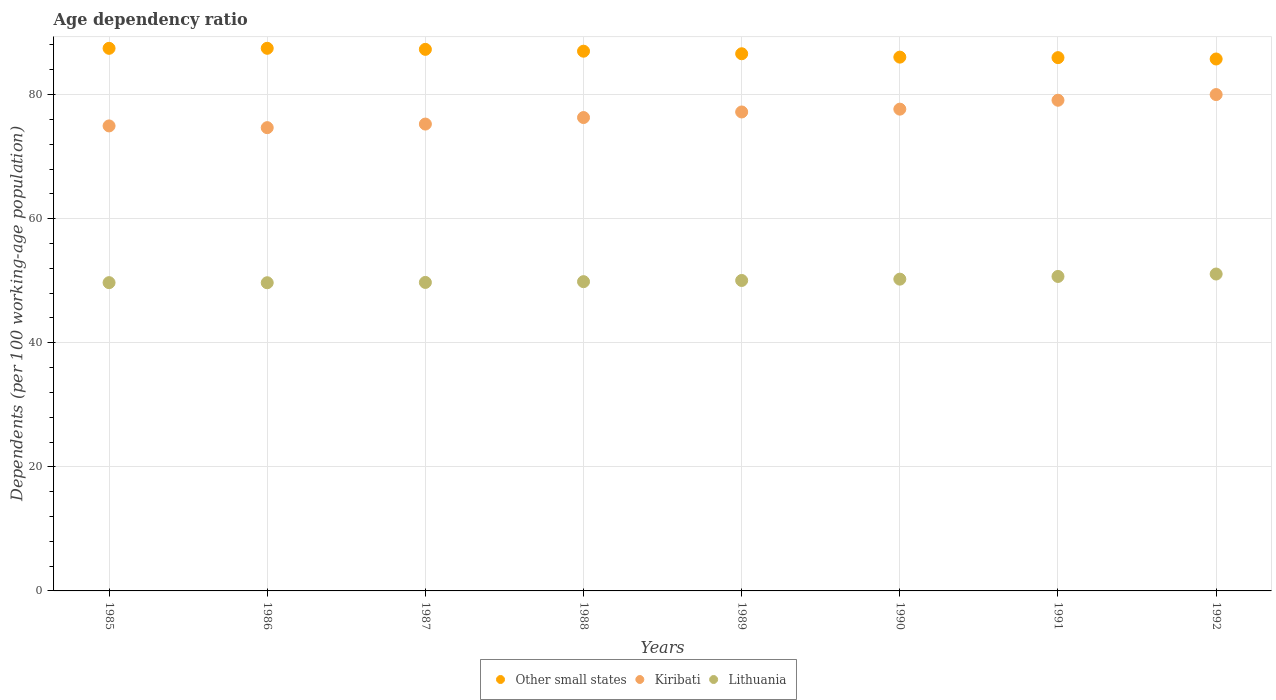How many different coloured dotlines are there?
Keep it short and to the point. 3. Is the number of dotlines equal to the number of legend labels?
Ensure brevity in your answer.  Yes. What is the age dependency ratio in in Lithuania in 1992?
Offer a terse response. 51.08. Across all years, what is the maximum age dependency ratio in in Kiribati?
Offer a terse response. 80. Across all years, what is the minimum age dependency ratio in in Kiribati?
Make the answer very short. 74.67. In which year was the age dependency ratio in in Kiribati minimum?
Offer a terse response. 1986. What is the total age dependency ratio in in Other small states in the graph?
Keep it short and to the point. 693.47. What is the difference between the age dependency ratio in in Other small states in 1989 and that in 1992?
Offer a very short reply. 0.84. What is the difference between the age dependency ratio in in Other small states in 1989 and the age dependency ratio in in Kiribati in 1986?
Ensure brevity in your answer.  11.91. What is the average age dependency ratio in in Other small states per year?
Give a very brief answer. 86.68. In the year 1986, what is the difference between the age dependency ratio in in Lithuania and age dependency ratio in in Kiribati?
Keep it short and to the point. -25. In how many years, is the age dependency ratio in in Other small states greater than 48 %?
Give a very brief answer. 8. What is the ratio of the age dependency ratio in in Kiribati in 1988 to that in 1990?
Give a very brief answer. 0.98. Is the age dependency ratio in in Other small states in 1990 less than that in 1991?
Your response must be concise. No. Is the difference between the age dependency ratio in in Lithuania in 1987 and 1992 greater than the difference between the age dependency ratio in in Kiribati in 1987 and 1992?
Offer a terse response. Yes. What is the difference between the highest and the second highest age dependency ratio in in Kiribati?
Your answer should be compact. 0.92. What is the difference between the highest and the lowest age dependency ratio in in Kiribati?
Offer a terse response. 5.33. Is it the case that in every year, the sum of the age dependency ratio in in Other small states and age dependency ratio in in Lithuania  is greater than the age dependency ratio in in Kiribati?
Provide a succinct answer. Yes. Is the age dependency ratio in in Lithuania strictly greater than the age dependency ratio in in Other small states over the years?
Provide a short and direct response. No. Is the age dependency ratio in in Other small states strictly less than the age dependency ratio in in Kiribati over the years?
Give a very brief answer. No. What is the title of the graph?
Provide a short and direct response. Age dependency ratio. Does "Argentina" appear as one of the legend labels in the graph?
Give a very brief answer. No. What is the label or title of the Y-axis?
Your answer should be compact. Dependents (per 100 working-age population). What is the Dependents (per 100 working-age population) of Other small states in 1985?
Offer a very short reply. 87.45. What is the Dependents (per 100 working-age population) of Kiribati in 1985?
Ensure brevity in your answer.  74.95. What is the Dependents (per 100 working-age population) of Lithuania in 1985?
Give a very brief answer. 49.69. What is the Dependents (per 100 working-age population) in Other small states in 1986?
Provide a short and direct response. 87.46. What is the Dependents (per 100 working-age population) of Kiribati in 1986?
Give a very brief answer. 74.67. What is the Dependents (per 100 working-age population) of Lithuania in 1986?
Your response must be concise. 49.67. What is the Dependents (per 100 working-age population) of Other small states in 1987?
Keep it short and to the point. 87.29. What is the Dependents (per 100 working-age population) in Kiribati in 1987?
Provide a succinct answer. 75.24. What is the Dependents (per 100 working-age population) of Lithuania in 1987?
Provide a succinct answer. 49.72. What is the Dependents (per 100 working-age population) in Other small states in 1988?
Provide a short and direct response. 86.99. What is the Dependents (per 100 working-age population) in Kiribati in 1988?
Give a very brief answer. 76.29. What is the Dependents (per 100 working-age population) in Lithuania in 1988?
Your answer should be very brief. 49.84. What is the Dependents (per 100 working-age population) of Other small states in 1989?
Your response must be concise. 86.58. What is the Dependents (per 100 working-age population) in Kiribati in 1989?
Keep it short and to the point. 77.19. What is the Dependents (per 100 working-age population) in Lithuania in 1989?
Your answer should be very brief. 50.04. What is the Dependents (per 100 working-age population) of Other small states in 1990?
Provide a short and direct response. 86.03. What is the Dependents (per 100 working-age population) in Kiribati in 1990?
Your answer should be very brief. 77.65. What is the Dependents (per 100 working-age population) of Lithuania in 1990?
Your answer should be compact. 50.25. What is the Dependents (per 100 working-age population) of Other small states in 1991?
Offer a terse response. 85.95. What is the Dependents (per 100 working-age population) of Kiribati in 1991?
Provide a short and direct response. 79.08. What is the Dependents (per 100 working-age population) in Lithuania in 1991?
Provide a short and direct response. 50.68. What is the Dependents (per 100 working-age population) of Other small states in 1992?
Offer a very short reply. 85.73. What is the Dependents (per 100 working-age population) of Kiribati in 1992?
Your answer should be compact. 80. What is the Dependents (per 100 working-age population) in Lithuania in 1992?
Make the answer very short. 51.08. Across all years, what is the maximum Dependents (per 100 working-age population) of Other small states?
Provide a short and direct response. 87.46. Across all years, what is the maximum Dependents (per 100 working-age population) of Kiribati?
Offer a very short reply. 80. Across all years, what is the maximum Dependents (per 100 working-age population) of Lithuania?
Offer a very short reply. 51.08. Across all years, what is the minimum Dependents (per 100 working-age population) in Other small states?
Your answer should be very brief. 85.73. Across all years, what is the minimum Dependents (per 100 working-age population) of Kiribati?
Your answer should be compact. 74.67. Across all years, what is the minimum Dependents (per 100 working-age population) of Lithuania?
Offer a terse response. 49.67. What is the total Dependents (per 100 working-age population) in Other small states in the graph?
Make the answer very short. 693.47. What is the total Dependents (per 100 working-age population) of Kiribati in the graph?
Your answer should be very brief. 615.07. What is the total Dependents (per 100 working-age population) of Lithuania in the graph?
Give a very brief answer. 400.97. What is the difference between the Dependents (per 100 working-age population) of Other small states in 1985 and that in 1986?
Give a very brief answer. -0. What is the difference between the Dependents (per 100 working-age population) in Kiribati in 1985 and that in 1986?
Offer a terse response. 0.28. What is the difference between the Dependents (per 100 working-age population) in Lithuania in 1985 and that in 1986?
Your response must be concise. 0.02. What is the difference between the Dependents (per 100 working-age population) in Other small states in 1985 and that in 1987?
Offer a terse response. 0.16. What is the difference between the Dependents (per 100 working-age population) of Kiribati in 1985 and that in 1987?
Your response must be concise. -0.3. What is the difference between the Dependents (per 100 working-age population) in Lithuania in 1985 and that in 1987?
Keep it short and to the point. -0.04. What is the difference between the Dependents (per 100 working-age population) in Other small states in 1985 and that in 1988?
Your answer should be very brief. 0.46. What is the difference between the Dependents (per 100 working-age population) of Kiribati in 1985 and that in 1988?
Make the answer very short. -1.35. What is the difference between the Dependents (per 100 working-age population) of Lithuania in 1985 and that in 1988?
Give a very brief answer. -0.16. What is the difference between the Dependents (per 100 working-age population) in Other small states in 1985 and that in 1989?
Make the answer very short. 0.87. What is the difference between the Dependents (per 100 working-age population) of Kiribati in 1985 and that in 1989?
Provide a succinct answer. -2.25. What is the difference between the Dependents (per 100 working-age population) of Lithuania in 1985 and that in 1989?
Keep it short and to the point. -0.35. What is the difference between the Dependents (per 100 working-age population) of Other small states in 1985 and that in 1990?
Provide a short and direct response. 1.42. What is the difference between the Dependents (per 100 working-age population) of Kiribati in 1985 and that in 1990?
Offer a very short reply. -2.7. What is the difference between the Dependents (per 100 working-age population) in Lithuania in 1985 and that in 1990?
Make the answer very short. -0.56. What is the difference between the Dependents (per 100 working-age population) of Other small states in 1985 and that in 1991?
Ensure brevity in your answer.  1.5. What is the difference between the Dependents (per 100 working-age population) in Kiribati in 1985 and that in 1991?
Offer a terse response. -4.14. What is the difference between the Dependents (per 100 working-age population) of Lithuania in 1985 and that in 1991?
Your answer should be very brief. -1. What is the difference between the Dependents (per 100 working-age population) of Other small states in 1985 and that in 1992?
Offer a terse response. 1.72. What is the difference between the Dependents (per 100 working-age population) of Kiribati in 1985 and that in 1992?
Your answer should be very brief. -5.05. What is the difference between the Dependents (per 100 working-age population) of Lithuania in 1985 and that in 1992?
Make the answer very short. -1.39. What is the difference between the Dependents (per 100 working-age population) of Other small states in 1986 and that in 1987?
Provide a succinct answer. 0.17. What is the difference between the Dependents (per 100 working-age population) in Kiribati in 1986 and that in 1987?
Offer a terse response. -0.58. What is the difference between the Dependents (per 100 working-age population) in Lithuania in 1986 and that in 1987?
Your answer should be compact. -0.05. What is the difference between the Dependents (per 100 working-age population) of Other small states in 1986 and that in 1988?
Make the answer very short. 0.47. What is the difference between the Dependents (per 100 working-age population) of Kiribati in 1986 and that in 1988?
Offer a terse response. -1.63. What is the difference between the Dependents (per 100 working-age population) of Lithuania in 1986 and that in 1988?
Make the answer very short. -0.17. What is the difference between the Dependents (per 100 working-age population) in Other small states in 1986 and that in 1989?
Provide a short and direct response. 0.88. What is the difference between the Dependents (per 100 working-age population) in Kiribati in 1986 and that in 1989?
Your response must be concise. -2.53. What is the difference between the Dependents (per 100 working-age population) in Lithuania in 1986 and that in 1989?
Provide a short and direct response. -0.37. What is the difference between the Dependents (per 100 working-age population) of Other small states in 1986 and that in 1990?
Your answer should be compact. 1.42. What is the difference between the Dependents (per 100 working-age population) of Kiribati in 1986 and that in 1990?
Offer a very short reply. -2.98. What is the difference between the Dependents (per 100 working-age population) of Lithuania in 1986 and that in 1990?
Offer a very short reply. -0.58. What is the difference between the Dependents (per 100 working-age population) of Other small states in 1986 and that in 1991?
Give a very brief answer. 1.51. What is the difference between the Dependents (per 100 working-age population) in Kiribati in 1986 and that in 1991?
Offer a terse response. -4.42. What is the difference between the Dependents (per 100 working-age population) of Lithuania in 1986 and that in 1991?
Provide a short and direct response. -1.01. What is the difference between the Dependents (per 100 working-age population) of Other small states in 1986 and that in 1992?
Offer a very short reply. 1.72. What is the difference between the Dependents (per 100 working-age population) in Kiribati in 1986 and that in 1992?
Offer a terse response. -5.33. What is the difference between the Dependents (per 100 working-age population) of Lithuania in 1986 and that in 1992?
Your response must be concise. -1.41. What is the difference between the Dependents (per 100 working-age population) of Other small states in 1987 and that in 1988?
Offer a terse response. 0.3. What is the difference between the Dependents (per 100 working-age population) in Kiribati in 1987 and that in 1988?
Provide a short and direct response. -1.05. What is the difference between the Dependents (per 100 working-age population) in Lithuania in 1987 and that in 1988?
Offer a terse response. -0.12. What is the difference between the Dependents (per 100 working-age population) in Other small states in 1987 and that in 1989?
Ensure brevity in your answer.  0.71. What is the difference between the Dependents (per 100 working-age population) of Kiribati in 1987 and that in 1989?
Provide a succinct answer. -1.95. What is the difference between the Dependents (per 100 working-age population) of Lithuania in 1987 and that in 1989?
Provide a succinct answer. -0.32. What is the difference between the Dependents (per 100 working-age population) of Other small states in 1987 and that in 1990?
Give a very brief answer. 1.25. What is the difference between the Dependents (per 100 working-age population) of Kiribati in 1987 and that in 1990?
Give a very brief answer. -2.4. What is the difference between the Dependents (per 100 working-age population) of Lithuania in 1987 and that in 1990?
Ensure brevity in your answer.  -0.53. What is the difference between the Dependents (per 100 working-age population) of Other small states in 1987 and that in 1991?
Offer a very short reply. 1.34. What is the difference between the Dependents (per 100 working-age population) in Kiribati in 1987 and that in 1991?
Your answer should be very brief. -3.84. What is the difference between the Dependents (per 100 working-age population) in Lithuania in 1987 and that in 1991?
Your answer should be compact. -0.96. What is the difference between the Dependents (per 100 working-age population) of Other small states in 1987 and that in 1992?
Provide a short and direct response. 1.55. What is the difference between the Dependents (per 100 working-age population) of Kiribati in 1987 and that in 1992?
Make the answer very short. -4.75. What is the difference between the Dependents (per 100 working-age population) of Lithuania in 1987 and that in 1992?
Ensure brevity in your answer.  -1.36. What is the difference between the Dependents (per 100 working-age population) of Other small states in 1988 and that in 1989?
Your response must be concise. 0.41. What is the difference between the Dependents (per 100 working-age population) of Kiribati in 1988 and that in 1989?
Offer a terse response. -0.9. What is the difference between the Dependents (per 100 working-age population) in Lithuania in 1988 and that in 1989?
Your answer should be compact. -0.19. What is the difference between the Dependents (per 100 working-age population) of Other small states in 1988 and that in 1990?
Make the answer very short. 0.96. What is the difference between the Dependents (per 100 working-age population) of Kiribati in 1988 and that in 1990?
Your answer should be very brief. -1.35. What is the difference between the Dependents (per 100 working-age population) of Lithuania in 1988 and that in 1990?
Keep it short and to the point. -0.41. What is the difference between the Dependents (per 100 working-age population) in Other small states in 1988 and that in 1991?
Ensure brevity in your answer.  1.04. What is the difference between the Dependents (per 100 working-age population) of Kiribati in 1988 and that in 1991?
Ensure brevity in your answer.  -2.79. What is the difference between the Dependents (per 100 working-age population) in Lithuania in 1988 and that in 1991?
Keep it short and to the point. -0.84. What is the difference between the Dependents (per 100 working-age population) of Other small states in 1988 and that in 1992?
Your answer should be compact. 1.26. What is the difference between the Dependents (per 100 working-age population) in Kiribati in 1988 and that in 1992?
Provide a succinct answer. -3.7. What is the difference between the Dependents (per 100 working-age population) in Lithuania in 1988 and that in 1992?
Your response must be concise. -1.23. What is the difference between the Dependents (per 100 working-age population) in Other small states in 1989 and that in 1990?
Keep it short and to the point. 0.54. What is the difference between the Dependents (per 100 working-age population) of Kiribati in 1989 and that in 1990?
Your answer should be very brief. -0.45. What is the difference between the Dependents (per 100 working-age population) in Lithuania in 1989 and that in 1990?
Your response must be concise. -0.21. What is the difference between the Dependents (per 100 working-age population) in Other small states in 1989 and that in 1991?
Your response must be concise. 0.63. What is the difference between the Dependents (per 100 working-age population) of Kiribati in 1989 and that in 1991?
Give a very brief answer. -1.89. What is the difference between the Dependents (per 100 working-age population) of Lithuania in 1989 and that in 1991?
Ensure brevity in your answer.  -0.65. What is the difference between the Dependents (per 100 working-age population) in Other small states in 1989 and that in 1992?
Your answer should be very brief. 0.84. What is the difference between the Dependents (per 100 working-age population) in Kiribati in 1989 and that in 1992?
Provide a succinct answer. -2.81. What is the difference between the Dependents (per 100 working-age population) of Lithuania in 1989 and that in 1992?
Your response must be concise. -1.04. What is the difference between the Dependents (per 100 working-age population) in Other small states in 1990 and that in 1991?
Keep it short and to the point. 0.08. What is the difference between the Dependents (per 100 working-age population) in Kiribati in 1990 and that in 1991?
Your answer should be compact. -1.44. What is the difference between the Dependents (per 100 working-age population) in Lithuania in 1990 and that in 1991?
Ensure brevity in your answer.  -0.43. What is the difference between the Dependents (per 100 working-age population) of Other small states in 1990 and that in 1992?
Keep it short and to the point. 0.3. What is the difference between the Dependents (per 100 working-age population) in Kiribati in 1990 and that in 1992?
Keep it short and to the point. -2.35. What is the difference between the Dependents (per 100 working-age population) in Lithuania in 1990 and that in 1992?
Your answer should be compact. -0.83. What is the difference between the Dependents (per 100 working-age population) of Other small states in 1991 and that in 1992?
Give a very brief answer. 0.22. What is the difference between the Dependents (per 100 working-age population) in Kiribati in 1991 and that in 1992?
Ensure brevity in your answer.  -0.92. What is the difference between the Dependents (per 100 working-age population) of Lithuania in 1991 and that in 1992?
Ensure brevity in your answer.  -0.39. What is the difference between the Dependents (per 100 working-age population) in Other small states in 1985 and the Dependents (per 100 working-age population) in Kiribati in 1986?
Keep it short and to the point. 12.79. What is the difference between the Dependents (per 100 working-age population) of Other small states in 1985 and the Dependents (per 100 working-age population) of Lithuania in 1986?
Your response must be concise. 37.78. What is the difference between the Dependents (per 100 working-age population) in Kiribati in 1985 and the Dependents (per 100 working-age population) in Lithuania in 1986?
Provide a succinct answer. 25.28. What is the difference between the Dependents (per 100 working-age population) in Other small states in 1985 and the Dependents (per 100 working-age population) in Kiribati in 1987?
Provide a succinct answer. 12.21. What is the difference between the Dependents (per 100 working-age population) of Other small states in 1985 and the Dependents (per 100 working-age population) of Lithuania in 1987?
Keep it short and to the point. 37.73. What is the difference between the Dependents (per 100 working-age population) of Kiribati in 1985 and the Dependents (per 100 working-age population) of Lithuania in 1987?
Provide a short and direct response. 25.23. What is the difference between the Dependents (per 100 working-age population) in Other small states in 1985 and the Dependents (per 100 working-age population) in Kiribati in 1988?
Provide a short and direct response. 11.16. What is the difference between the Dependents (per 100 working-age population) in Other small states in 1985 and the Dependents (per 100 working-age population) in Lithuania in 1988?
Ensure brevity in your answer.  37.61. What is the difference between the Dependents (per 100 working-age population) in Kiribati in 1985 and the Dependents (per 100 working-age population) in Lithuania in 1988?
Ensure brevity in your answer.  25.1. What is the difference between the Dependents (per 100 working-age population) in Other small states in 1985 and the Dependents (per 100 working-age population) in Kiribati in 1989?
Provide a succinct answer. 10.26. What is the difference between the Dependents (per 100 working-age population) of Other small states in 1985 and the Dependents (per 100 working-age population) of Lithuania in 1989?
Provide a succinct answer. 37.42. What is the difference between the Dependents (per 100 working-age population) of Kiribati in 1985 and the Dependents (per 100 working-age population) of Lithuania in 1989?
Your answer should be compact. 24.91. What is the difference between the Dependents (per 100 working-age population) in Other small states in 1985 and the Dependents (per 100 working-age population) in Kiribati in 1990?
Ensure brevity in your answer.  9.8. What is the difference between the Dependents (per 100 working-age population) in Other small states in 1985 and the Dependents (per 100 working-age population) in Lithuania in 1990?
Give a very brief answer. 37.2. What is the difference between the Dependents (per 100 working-age population) in Kiribati in 1985 and the Dependents (per 100 working-age population) in Lithuania in 1990?
Make the answer very short. 24.7. What is the difference between the Dependents (per 100 working-age population) in Other small states in 1985 and the Dependents (per 100 working-age population) in Kiribati in 1991?
Give a very brief answer. 8.37. What is the difference between the Dependents (per 100 working-age population) in Other small states in 1985 and the Dependents (per 100 working-age population) in Lithuania in 1991?
Your answer should be very brief. 36.77. What is the difference between the Dependents (per 100 working-age population) of Kiribati in 1985 and the Dependents (per 100 working-age population) of Lithuania in 1991?
Ensure brevity in your answer.  24.26. What is the difference between the Dependents (per 100 working-age population) of Other small states in 1985 and the Dependents (per 100 working-age population) of Kiribati in 1992?
Your answer should be very brief. 7.45. What is the difference between the Dependents (per 100 working-age population) of Other small states in 1985 and the Dependents (per 100 working-age population) of Lithuania in 1992?
Provide a short and direct response. 36.38. What is the difference between the Dependents (per 100 working-age population) in Kiribati in 1985 and the Dependents (per 100 working-age population) in Lithuania in 1992?
Make the answer very short. 23.87. What is the difference between the Dependents (per 100 working-age population) in Other small states in 1986 and the Dependents (per 100 working-age population) in Kiribati in 1987?
Make the answer very short. 12.21. What is the difference between the Dependents (per 100 working-age population) of Other small states in 1986 and the Dependents (per 100 working-age population) of Lithuania in 1987?
Your answer should be compact. 37.74. What is the difference between the Dependents (per 100 working-age population) in Kiribati in 1986 and the Dependents (per 100 working-age population) in Lithuania in 1987?
Offer a very short reply. 24.95. What is the difference between the Dependents (per 100 working-age population) in Other small states in 1986 and the Dependents (per 100 working-age population) in Kiribati in 1988?
Provide a succinct answer. 11.16. What is the difference between the Dependents (per 100 working-age population) of Other small states in 1986 and the Dependents (per 100 working-age population) of Lithuania in 1988?
Your answer should be very brief. 37.61. What is the difference between the Dependents (per 100 working-age population) in Kiribati in 1986 and the Dependents (per 100 working-age population) in Lithuania in 1988?
Keep it short and to the point. 24.82. What is the difference between the Dependents (per 100 working-age population) in Other small states in 1986 and the Dependents (per 100 working-age population) in Kiribati in 1989?
Ensure brevity in your answer.  10.26. What is the difference between the Dependents (per 100 working-age population) of Other small states in 1986 and the Dependents (per 100 working-age population) of Lithuania in 1989?
Provide a short and direct response. 37.42. What is the difference between the Dependents (per 100 working-age population) in Kiribati in 1986 and the Dependents (per 100 working-age population) in Lithuania in 1989?
Provide a short and direct response. 24.63. What is the difference between the Dependents (per 100 working-age population) in Other small states in 1986 and the Dependents (per 100 working-age population) in Kiribati in 1990?
Give a very brief answer. 9.81. What is the difference between the Dependents (per 100 working-age population) in Other small states in 1986 and the Dependents (per 100 working-age population) in Lithuania in 1990?
Ensure brevity in your answer.  37.21. What is the difference between the Dependents (per 100 working-age population) in Kiribati in 1986 and the Dependents (per 100 working-age population) in Lithuania in 1990?
Your answer should be compact. 24.42. What is the difference between the Dependents (per 100 working-age population) of Other small states in 1986 and the Dependents (per 100 working-age population) of Kiribati in 1991?
Your answer should be compact. 8.37. What is the difference between the Dependents (per 100 working-age population) of Other small states in 1986 and the Dependents (per 100 working-age population) of Lithuania in 1991?
Your response must be concise. 36.77. What is the difference between the Dependents (per 100 working-age population) in Kiribati in 1986 and the Dependents (per 100 working-age population) in Lithuania in 1991?
Give a very brief answer. 23.98. What is the difference between the Dependents (per 100 working-age population) in Other small states in 1986 and the Dependents (per 100 working-age population) in Kiribati in 1992?
Your response must be concise. 7.46. What is the difference between the Dependents (per 100 working-age population) in Other small states in 1986 and the Dependents (per 100 working-age population) in Lithuania in 1992?
Provide a short and direct response. 36.38. What is the difference between the Dependents (per 100 working-age population) of Kiribati in 1986 and the Dependents (per 100 working-age population) of Lithuania in 1992?
Provide a succinct answer. 23.59. What is the difference between the Dependents (per 100 working-age population) of Other small states in 1987 and the Dependents (per 100 working-age population) of Kiribati in 1988?
Make the answer very short. 10.99. What is the difference between the Dependents (per 100 working-age population) of Other small states in 1987 and the Dependents (per 100 working-age population) of Lithuania in 1988?
Provide a succinct answer. 37.44. What is the difference between the Dependents (per 100 working-age population) in Kiribati in 1987 and the Dependents (per 100 working-age population) in Lithuania in 1988?
Give a very brief answer. 25.4. What is the difference between the Dependents (per 100 working-age population) of Other small states in 1987 and the Dependents (per 100 working-age population) of Kiribati in 1989?
Your answer should be compact. 10.09. What is the difference between the Dependents (per 100 working-age population) of Other small states in 1987 and the Dependents (per 100 working-age population) of Lithuania in 1989?
Provide a succinct answer. 37.25. What is the difference between the Dependents (per 100 working-age population) in Kiribati in 1987 and the Dependents (per 100 working-age population) in Lithuania in 1989?
Your answer should be compact. 25.21. What is the difference between the Dependents (per 100 working-age population) of Other small states in 1987 and the Dependents (per 100 working-age population) of Kiribati in 1990?
Provide a short and direct response. 9.64. What is the difference between the Dependents (per 100 working-age population) of Other small states in 1987 and the Dependents (per 100 working-age population) of Lithuania in 1990?
Give a very brief answer. 37.04. What is the difference between the Dependents (per 100 working-age population) in Kiribati in 1987 and the Dependents (per 100 working-age population) in Lithuania in 1990?
Your answer should be compact. 24.99. What is the difference between the Dependents (per 100 working-age population) in Other small states in 1987 and the Dependents (per 100 working-age population) in Kiribati in 1991?
Offer a very short reply. 8.2. What is the difference between the Dependents (per 100 working-age population) in Other small states in 1987 and the Dependents (per 100 working-age population) in Lithuania in 1991?
Provide a short and direct response. 36.6. What is the difference between the Dependents (per 100 working-age population) in Kiribati in 1987 and the Dependents (per 100 working-age population) in Lithuania in 1991?
Give a very brief answer. 24.56. What is the difference between the Dependents (per 100 working-age population) of Other small states in 1987 and the Dependents (per 100 working-age population) of Kiribati in 1992?
Provide a short and direct response. 7.29. What is the difference between the Dependents (per 100 working-age population) of Other small states in 1987 and the Dependents (per 100 working-age population) of Lithuania in 1992?
Give a very brief answer. 36.21. What is the difference between the Dependents (per 100 working-age population) in Kiribati in 1987 and the Dependents (per 100 working-age population) in Lithuania in 1992?
Offer a terse response. 24.17. What is the difference between the Dependents (per 100 working-age population) in Other small states in 1988 and the Dependents (per 100 working-age population) in Kiribati in 1989?
Make the answer very short. 9.8. What is the difference between the Dependents (per 100 working-age population) in Other small states in 1988 and the Dependents (per 100 working-age population) in Lithuania in 1989?
Your answer should be very brief. 36.95. What is the difference between the Dependents (per 100 working-age population) in Kiribati in 1988 and the Dependents (per 100 working-age population) in Lithuania in 1989?
Give a very brief answer. 26.26. What is the difference between the Dependents (per 100 working-age population) in Other small states in 1988 and the Dependents (per 100 working-age population) in Kiribati in 1990?
Give a very brief answer. 9.34. What is the difference between the Dependents (per 100 working-age population) in Other small states in 1988 and the Dependents (per 100 working-age population) in Lithuania in 1990?
Offer a terse response. 36.74. What is the difference between the Dependents (per 100 working-age population) in Kiribati in 1988 and the Dependents (per 100 working-age population) in Lithuania in 1990?
Ensure brevity in your answer.  26.05. What is the difference between the Dependents (per 100 working-age population) in Other small states in 1988 and the Dependents (per 100 working-age population) in Kiribati in 1991?
Ensure brevity in your answer.  7.91. What is the difference between the Dependents (per 100 working-age population) in Other small states in 1988 and the Dependents (per 100 working-age population) in Lithuania in 1991?
Your answer should be very brief. 36.3. What is the difference between the Dependents (per 100 working-age population) in Kiribati in 1988 and the Dependents (per 100 working-age population) in Lithuania in 1991?
Keep it short and to the point. 25.61. What is the difference between the Dependents (per 100 working-age population) of Other small states in 1988 and the Dependents (per 100 working-age population) of Kiribati in 1992?
Ensure brevity in your answer.  6.99. What is the difference between the Dependents (per 100 working-age population) of Other small states in 1988 and the Dependents (per 100 working-age population) of Lithuania in 1992?
Your answer should be compact. 35.91. What is the difference between the Dependents (per 100 working-age population) in Kiribati in 1988 and the Dependents (per 100 working-age population) in Lithuania in 1992?
Keep it short and to the point. 25.22. What is the difference between the Dependents (per 100 working-age population) of Other small states in 1989 and the Dependents (per 100 working-age population) of Kiribati in 1990?
Provide a succinct answer. 8.93. What is the difference between the Dependents (per 100 working-age population) of Other small states in 1989 and the Dependents (per 100 working-age population) of Lithuania in 1990?
Provide a short and direct response. 36.33. What is the difference between the Dependents (per 100 working-age population) in Kiribati in 1989 and the Dependents (per 100 working-age population) in Lithuania in 1990?
Keep it short and to the point. 26.94. What is the difference between the Dependents (per 100 working-age population) of Other small states in 1989 and the Dependents (per 100 working-age population) of Kiribati in 1991?
Offer a terse response. 7.49. What is the difference between the Dependents (per 100 working-age population) in Other small states in 1989 and the Dependents (per 100 working-age population) in Lithuania in 1991?
Offer a very short reply. 35.89. What is the difference between the Dependents (per 100 working-age population) in Kiribati in 1989 and the Dependents (per 100 working-age population) in Lithuania in 1991?
Provide a short and direct response. 26.51. What is the difference between the Dependents (per 100 working-age population) of Other small states in 1989 and the Dependents (per 100 working-age population) of Kiribati in 1992?
Your response must be concise. 6.58. What is the difference between the Dependents (per 100 working-age population) in Other small states in 1989 and the Dependents (per 100 working-age population) in Lithuania in 1992?
Give a very brief answer. 35.5. What is the difference between the Dependents (per 100 working-age population) in Kiribati in 1989 and the Dependents (per 100 working-age population) in Lithuania in 1992?
Ensure brevity in your answer.  26.12. What is the difference between the Dependents (per 100 working-age population) of Other small states in 1990 and the Dependents (per 100 working-age population) of Kiribati in 1991?
Your answer should be compact. 6.95. What is the difference between the Dependents (per 100 working-age population) of Other small states in 1990 and the Dependents (per 100 working-age population) of Lithuania in 1991?
Your response must be concise. 35.35. What is the difference between the Dependents (per 100 working-age population) in Kiribati in 1990 and the Dependents (per 100 working-age population) in Lithuania in 1991?
Offer a terse response. 26.96. What is the difference between the Dependents (per 100 working-age population) in Other small states in 1990 and the Dependents (per 100 working-age population) in Kiribati in 1992?
Your answer should be compact. 6.03. What is the difference between the Dependents (per 100 working-age population) of Other small states in 1990 and the Dependents (per 100 working-age population) of Lithuania in 1992?
Your answer should be very brief. 34.96. What is the difference between the Dependents (per 100 working-age population) of Kiribati in 1990 and the Dependents (per 100 working-age population) of Lithuania in 1992?
Provide a succinct answer. 26.57. What is the difference between the Dependents (per 100 working-age population) in Other small states in 1991 and the Dependents (per 100 working-age population) in Kiribati in 1992?
Make the answer very short. 5.95. What is the difference between the Dependents (per 100 working-age population) of Other small states in 1991 and the Dependents (per 100 working-age population) of Lithuania in 1992?
Offer a very short reply. 34.87. What is the difference between the Dependents (per 100 working-age population) in Kiribati in 1991 and the Dependents (per 100 working-age population) in Lithuania in 1992?
Give a very brief answer. 28.01. What is the average Dependents (per 100 working-age population) in Other small states per year?
Provide a short and direct response. 86.68. What is the average Dependents (per 100 working-age population) in Kiribati per year?
Your answer should be very brief. 76.88. What is the average Dependents (per 100 working-age population) in Lithuania per year?
Your response must be concise. 50.12. In the year 1985, what is the difference between the Dependents (per 100 working-age population) of Other small states and Dependents (per 100 working-age population) of Kiribati?
Ensure brevity in your answer.  12.5. In the year 1985, what is the difference between the Dependents (per 100 working-age population) in Other small states and Dependents (per 100 working-age population) in Lithuania?
Ensure brevity in your answer.  37.77. In the year 1985, what is the difference between the Dependents (per 100 working-age population) in Kiribati and Dependents (per 100 working-age population) in Lithuania?
Your response must be concise. 25.26. In the year 1986, what is the difference between the Dependents (per 100 working-age population) in Other small states and Dependents (per 100 working-age population) in Kiribati?
Your response must be concise. 12.79. In the year 1986, what is the difference between the Dependents (per 100 working-age population) of Other small states and Dependents (per 100 working-age population) of Lithuania?
Give a very brief answer. 37.79. In the year 1986, what is the difference between the Dependents (per 100 working-age population) of Kiribati and Dependents (per 100 working-age population) of Lithuania?
Your answer should be very brief. 25. In the year 1987, what is the difference between the Dependents (per 100 working-age population) of Other small states and Dependents (per 100 working-age population) of Kiribati?
Your response must be concise. 12.04. In the year 1987, what is the difference between the Dependents (per 100 working-age population) in Other small states and Dependents (per 100 working-age population) in Lithuania?
Your response must be concise. 37.57. In the year 1987, what is the difference between the Dependents (per 100 working-age population) of Kiribati and Dependents (per 100 working-age population) of Lithuania?
Your answer should be compact. 25.52. In the year 1988, what is the difference between the Dependents (per 100 working-age population) in Other small states and Dependents (per 100 working-age population) in Kiribati?
Keep it short and to the point. 10.69. In the year 1988, what is the difference between the Dependents (per 100 working-age population) in Other small states and Dependents (per 100 working-age population) in Lithuania?
Give a very brief answer. 37.14. In the year 1988, what is the difference between the Dependents (per 100 working-age population) in Kiribati and Dependents (per 100 working-age population) in Lithuania?
Offer a very short reply. 26.45. In the year 1989, what is the difference between the Dependents (per 100 working-age population) of Other small states and Dependents (per 100 working-age population) of Kiribati?
Give a very brief answer. 9.38. In the year 1989, what is the difference between the Dependents (per 100 working-age population) in Other small states and Dependents (per 100 working-age population) in Lithuania?
Offer a terse response. 36.54. In the year 1989, what is the difference between the Dependents (per 100 working-age population) of Kiribati and Dependents (per 100 working-age population) of Lithuania?
Offer a terse response. 27.16. In the year 1990, what is the difference between the Dependents (per 100 working-age population) in Other small states and Dependents (per 100 working-age population) in Kiribati?
Give a very brief answer. 8.38. In the year 1990, what is the difference between the Dependents (per 100 working-age population) in Other small states and Dependents (per 100 working-age population) in Lithuania?
Your answer should be very brief. 35.78. In the year 1990, what is the difference between the Dependents (per 100 working-age population) of Kiribati and Dependents (per 100 working-age population) of Lithuania?
Offer a terse response. 27.4. In the year 1991, what is the difference between the Dependents (per 100 working-age population) in Other small states and Dependents (per 100 working-age population) in Kiribati?
Provide a short and direct response. 6.87. In the year 1991, what is the difference between the Dependents (per 100 working-age population) in Other small states and Dependents (per 100 working-age population) in Lithuania?
Offer a very short reply. 35.27. In the year 1991, what is the difference between the Dependents (per 100 working-age population) in Kiribati and Dependents (per 100 working-age population) in Lithuania?
Ensure brevity in your answer.  28.4. In the year 1992, what is the difference between the Dependents (per 100 working-age population) in Other small states and Dependents (per 100 working-age population) in Kiribati?
Provide a succinct answer. 5.73. In the year 1992, what is the difference between the Dependents (per 100 working-age population) of Other small states and Dependents (per 100 working-age population) of Lithuania?
Your response must be concise. 34.66. In the year 1992, what is the difference between the Dependents (per 100 working-age population) of Kiribati and Dependents (per 100 working-age population) of Lithuania?
Offer a terse response. 28.92. What is the ratio of the Dependents (per 100 working-age population) in Other small states in 1985 to that in 1986?
Offer a very short reply. 1. What is the ratio of the Dependents (per 100 working-age population) in Kiribati in 1985 to that in 1986?
Make the answer very short. 1. What is the ratio of the Dependents (per 100 working-age population) in Lithuania in 1985 to that in 1986?
Give a very brief answer. 1. What is the ratio of the Dependents (per 100 working-age population) of Other small states in 1985 to that in 1987?
Your answer should be very brief. 1. What is the ratio of the Dependents (per 100 working-age population) of Kiribati in 1985 to that in 1987?
Your response must be concise. 1. What is the ratio of the Dependents (per 100 working-age population) in Lithuania in 1985 to that in 1987?
Provide a short and direct response. 1. What is the ratio of the Dependents (per 100 working-age population) of Kiribati in 1985 to that in 1988?
Make the answer very short. 0.98. What is the ratio of the Dependents (per 100 working-age population) of Kiribati in 1985 to that in 1989?
Ensure brevity in your answer.  0.97. What is the ratio of the Dependents (per 100 working-age population) in Lithuania in 1985 to that in 1989?
Provide a short and direct response. 0.99. What is the ratio of the Dependents (per 100 working-age population) in Other small states in 1985 to that in 1990?
Offer a terse response. 1.02. What is the ratio of the Dependents (per 100 working-age population) of Kiribati in 1985 to that in 1990?
Your answer should be very brief. 0.97. What is the ratio of the Dependents (per 100 working-age population) of Lithuania in 1985 to that in 1990?
Offer a very short reply. 0.99. What is the ratio of the Dependents (per 100 working-age population) in Other small states in 1985 to that in 1991?
Provide a short and direct response. 1.02. What is the ratio of the Dependents (per 100 working-age population) in Kiribati in 1985 to that in 1991?
Ensure brevity in your answer.  0.95. What is the ratio of the Dependents (per 100 working-age population) of Lithuania in 1985 to that in 1991?
Keep it short and to the point. 0.98. What is the ratio of the Dependents (per 100 working-age population) of Kiribati in 1985 to that in 1992?
Make the answer very short. 0.94. What is the ratio of the Dependents (per 100 working-age population) of Lithuania in 1985 to that in 1992?
Give a very brief answer. 0.97. What is the ratio of the Dependents (per 100 working-age population) of Other small states in 1986 to that in 1988?
Your answer should be very brief. 1.01. What is the ratio of the Dependents (per 100 working-age population) of Kiribati in 1986 to that in 1988?
Provide a short and direct response. 0.98. What is the ratio of the Dependents (per 100 working-age population) in Lithuania in 1986 to that in 1988?
Ensure brevity in your answer.  1. What is the ratio of the Dependents (per 100 working-age population) of Other small states in 1986 to that in 1989?
Offer a terse response. 1.01. What is the ratio of the Dependents (per 100 working-age population) of Kiribati in 1986 to that in 1989?
Give a very brief answer. 0.97. What is the ratio of the Dependents (per 100 working-age population) in Other small states in 1986 to that in 1990?
Offer a terse response. 1.02. What is the ratio of the Dependents (per 100 working-age population) of Kiribati in 1986 to that in 1990?
Your answer should be very brief. 0.96. What is the ratio of the Dependents (per 100 working-age population) of Lithuania in 1986 to that in 1990?
Your response must be concise. 0.99. What is the ratio of the Dependents (per 100 working-age population) in Other small states in 1986 to that in 1991?
Give a very brief answer. 1.02. What is the ratio of the Dependents (per 100 working-age population) of Kiribati in 1986 to that in 1991?
Your answer should be compact. 0.94. What is the ratio of the Dependents (per 100 working-age population) in Other small states in 1986 to that in 1992?
Ensure brevity in your answer.  1.02. What is the ratio of the Dependents (per 100 working-age population) of Lithuania in 1986 to that in 1992?
Offer a very short reply. 0.97. What is the ratio of the Dependents (per 100 working-age population) of Other small states in 1987 to that in 1988?
Your response must be concise. 1. What is the ratio of the Dependents (per 100 working-age population) of Kiribati in 1987 to that in 1988?
Provide a succinct answer. 0.99. What is the ratio of the Dependents (per 100 working-age population) of Other small states in 1987 to that in 1989?
Make the answer very short. 1.01. What is the ratio of the Dependents (per 100 working-age population) in Kiribati in 1987 to that in 1989?
Your response must be concise. 0.97. What is the ratio of the Dependents (per 100 working-age population) in Lithuania in 1987 to that in 1989?
Your answer should be compact. 0.99. What is the ratio of the Dependents (per 100 working-age population) of Other small states in 1987 to that in 1990?
Provide a succinct answer. 1.01. What is the ratio of the Dependents (per 100 working-age population) in Kiribati in 1987 to that in 1990?
Your answer should be very brief. 0.97. What is the ratio of the Dependents (per 100 working-age population) of Other small states in 1987 to that in 1991?
Make the answer very short. 1.02. What is the ratio of the Dependents (per 100 working-age population) of Kiribati in 1987 to that in 1991?
Keep it short and to the point. 0.95. What is the ratio of the Dependents (per 100 working-age population) of Other small states in 1987 to that in 1992?
Give a very brief answer. 1.02. What is the ratio of the Dependents (per 100 working-age population) of Kiribati in 1987 to that in 1992?
Your response must be concise. 0.94. What is the ratio of the Dependents (per 100 working-age population) of Lithuania in 1987 to that in 1992?
Keep it short and to the point. 0.97. What is the ratio of the Dependents (per 100 working-age population) in Kiribati in 1988 to that in 1989?
Provide a short and direct response. 0.99. What is the ratio of the Dependents (per 100 working-age population) in Other small states in 1988 to that in 1990?
Give a very brief answer. 1.01. What is the ratio of the Dependents (per 100 working-age population) in Kiribati in 1988 to that in 1990?
Keep it short and to the point. 0.98. What is the ratio of the Dependents (per 100 working-age population) of Other small states in 1988 to that in 1991?
Your answer should be very brief. 1.01. What is the ratio of the Dependents (per 100 working-age population) of Kiribati in 1988 to that in 1991?
Your answer should be compact. 0.96. What is the ratio of the Dependents (per 100 working-age population) of Lithuania in 1988 to that in 1991?
Your answer should be compact. 0.98. What is the ratio of the Dependents (per 100 working-age population) of Other small states in 1988 to that in 1992?
Give a very brief answer. 1.01. What is the ratio of the Dependents (per 100 working-age population) of Kiribati in 1988 to that in 1992?
Keep it short and to the point. 0.95. What is the ratio of the Dependents (per 100 working-age population) in Lithuania in 1988 to that in 1992?
Your response must be concise. 0.98. What is the ratio of the Dependents (per 100 working-age population) in Other small states in 1989 to that in 1990?
Give a very brief answer. 1.01. What is the ratio of the Dependents (per 100 working-age population) of Kiribati in 1989 to that in 1990?
Provide a short and direct response. 0.99. What is the ratio of the Dependents (per 100 working-age population) of Lithuania in 1989 to that in 1990?
Ensure brevity in your answer.  1. What is the ratio of the Dependents (per 100 working-age population) of Other small states in 1989 to that in 1991?
Give a very brief answer. 1.01. What is the ratio of the Dependents (per 100 working-age population) of Kiribati in 1989 to that in 1991?
Offer a terse response. 0.98. What is the ratio of the Dependents (per 100 working-age population) of Lithuania in 1989 to that in 1991?
Ensure brevity in your answer.  0.99. What is the ratio of the Dependents (per 100 working-age population) in Other small states in 1989 to that in 1992?
Provide a succinct answer. 1.01. What is the ratio of the Dependents (per 100 working-age population) in Kiribati in 1989 to that in 1992?
Provide a succinct answer. 0.96. What is the ratio of the Dependents (per 100 working-age population) of Lithuania in 1989 to that in 1992?
Your response must be concise. 0.98. What is the ratio of the Dependents (per 100 working-age population) of Other small states in 1990 to that in 1991?
Offer a very short reply. 1. What is the ratio of the Dependents (per 100 working-age population) in Kiribati in 1990 to that in 1991?
Offer a terse response. 0.98. What is the ratio of the Dependents (per 100 working-age population) in Kiribati in 1990 to that in 1992?
Your answer should be compact. 0.97. What is the ratio of the Dependents (per 100 working-age population) in Lithuania in 1990 to that in 1992?
Keep it short and to the point. 0.98. What is the ratio of the Dependents (per 100 working-age population) in Kiribati in 1991 to that in 1992?
Your response must be concise. 0.99. What is the ratio of the Dependents (per 100 working-age population) in Lithuania in 1991 to that in 1992?
Make the answer very short. 0.99. What is the difference between the highest and the second highest Dependents (per 100 working-age population) in Other small states?
Your answer should be compact. 0. What is the difference between the highest and the second highest Dependents (per 100 working-age population) of Kiribati?
Provide a short and direct response. 0.92. What is the difference between the highest and the second highest Dependents (per 100 working-age population) in Lithuania?
Provide a short and direct response. 0.39. What is the difference between the highest and the lowest Dependents (per 100 working-age population) of Other small states?
Provide a short and direct response. 1.72. What is the difference between the highest and the lowest Dependents (per 100 working-age population) in Kiribati?
Offer a terse response. 5.33. What is the difference between the highest and the lowest Dependents (per 100 working-age population) of Lithuania?
Make the answer very short. 1.41. 